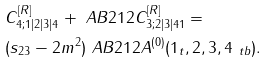Convert formula to latex. <formula><loc_0><loc_0><loc_500><loc_500>& C ^ { [ R ] } _ { 4 ; 1 | 2 | 3 | 4 } + \ A B 2 1 2 C ^ { [ R ] } _ { 3 ; 2 | 3 | 4 1 } = \\ & ( s _ { 2 3 } - 2 m ^ { 2 } ) \ A B 2 1 2 A ^ { ( 0 ) } ( 1 _ { t } , 2 , 3 , 4 _ { \ t b } ) .</formula> 